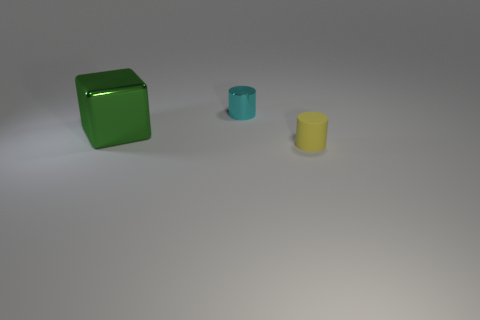Add 1 cyan cylinders. How many objects exist? 4 Subtract all blocks. How many objects are left? 2 Subtract 0 blue cubes. How many objects are left? 3 Subtract all green cylinders. Subtract all cyan spheres. How many cylinders are left? 2 Subtract all yellow rubber things. Subtract all big blocks. How many objects are left? 1 Add 1 small rubber things. How many small rubber things are left? 2 Add 3 large yellow shiny cylinders. How many large yellow shiny cylinders exist? 3 